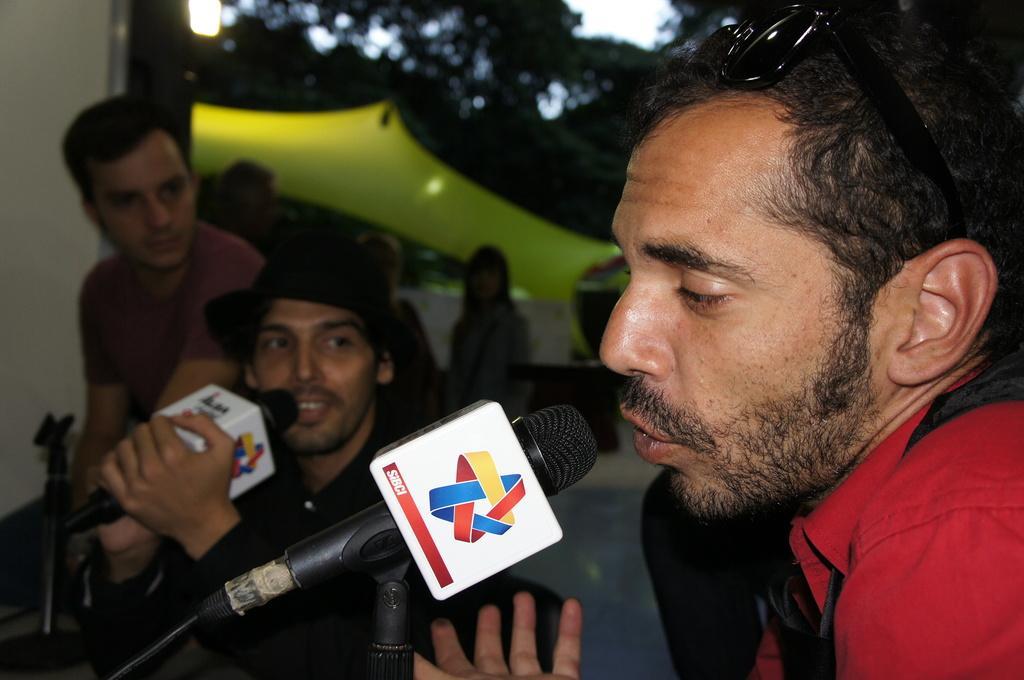How would you summarize this image in a sentence or two? On the right side of the image there is a man talking on the mic beside him there are two people where the man who is wearing a black shirt is holding a mic in his hand. In the background there are people standing. We can also see some trees and the sky. 